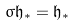Convert formula to latex. <formula><loc_0><loc_0><loc_500><loc_500>\sigma \mathfrak { h } _ { * } = \mathfrak { h } _ { * }</formula> 